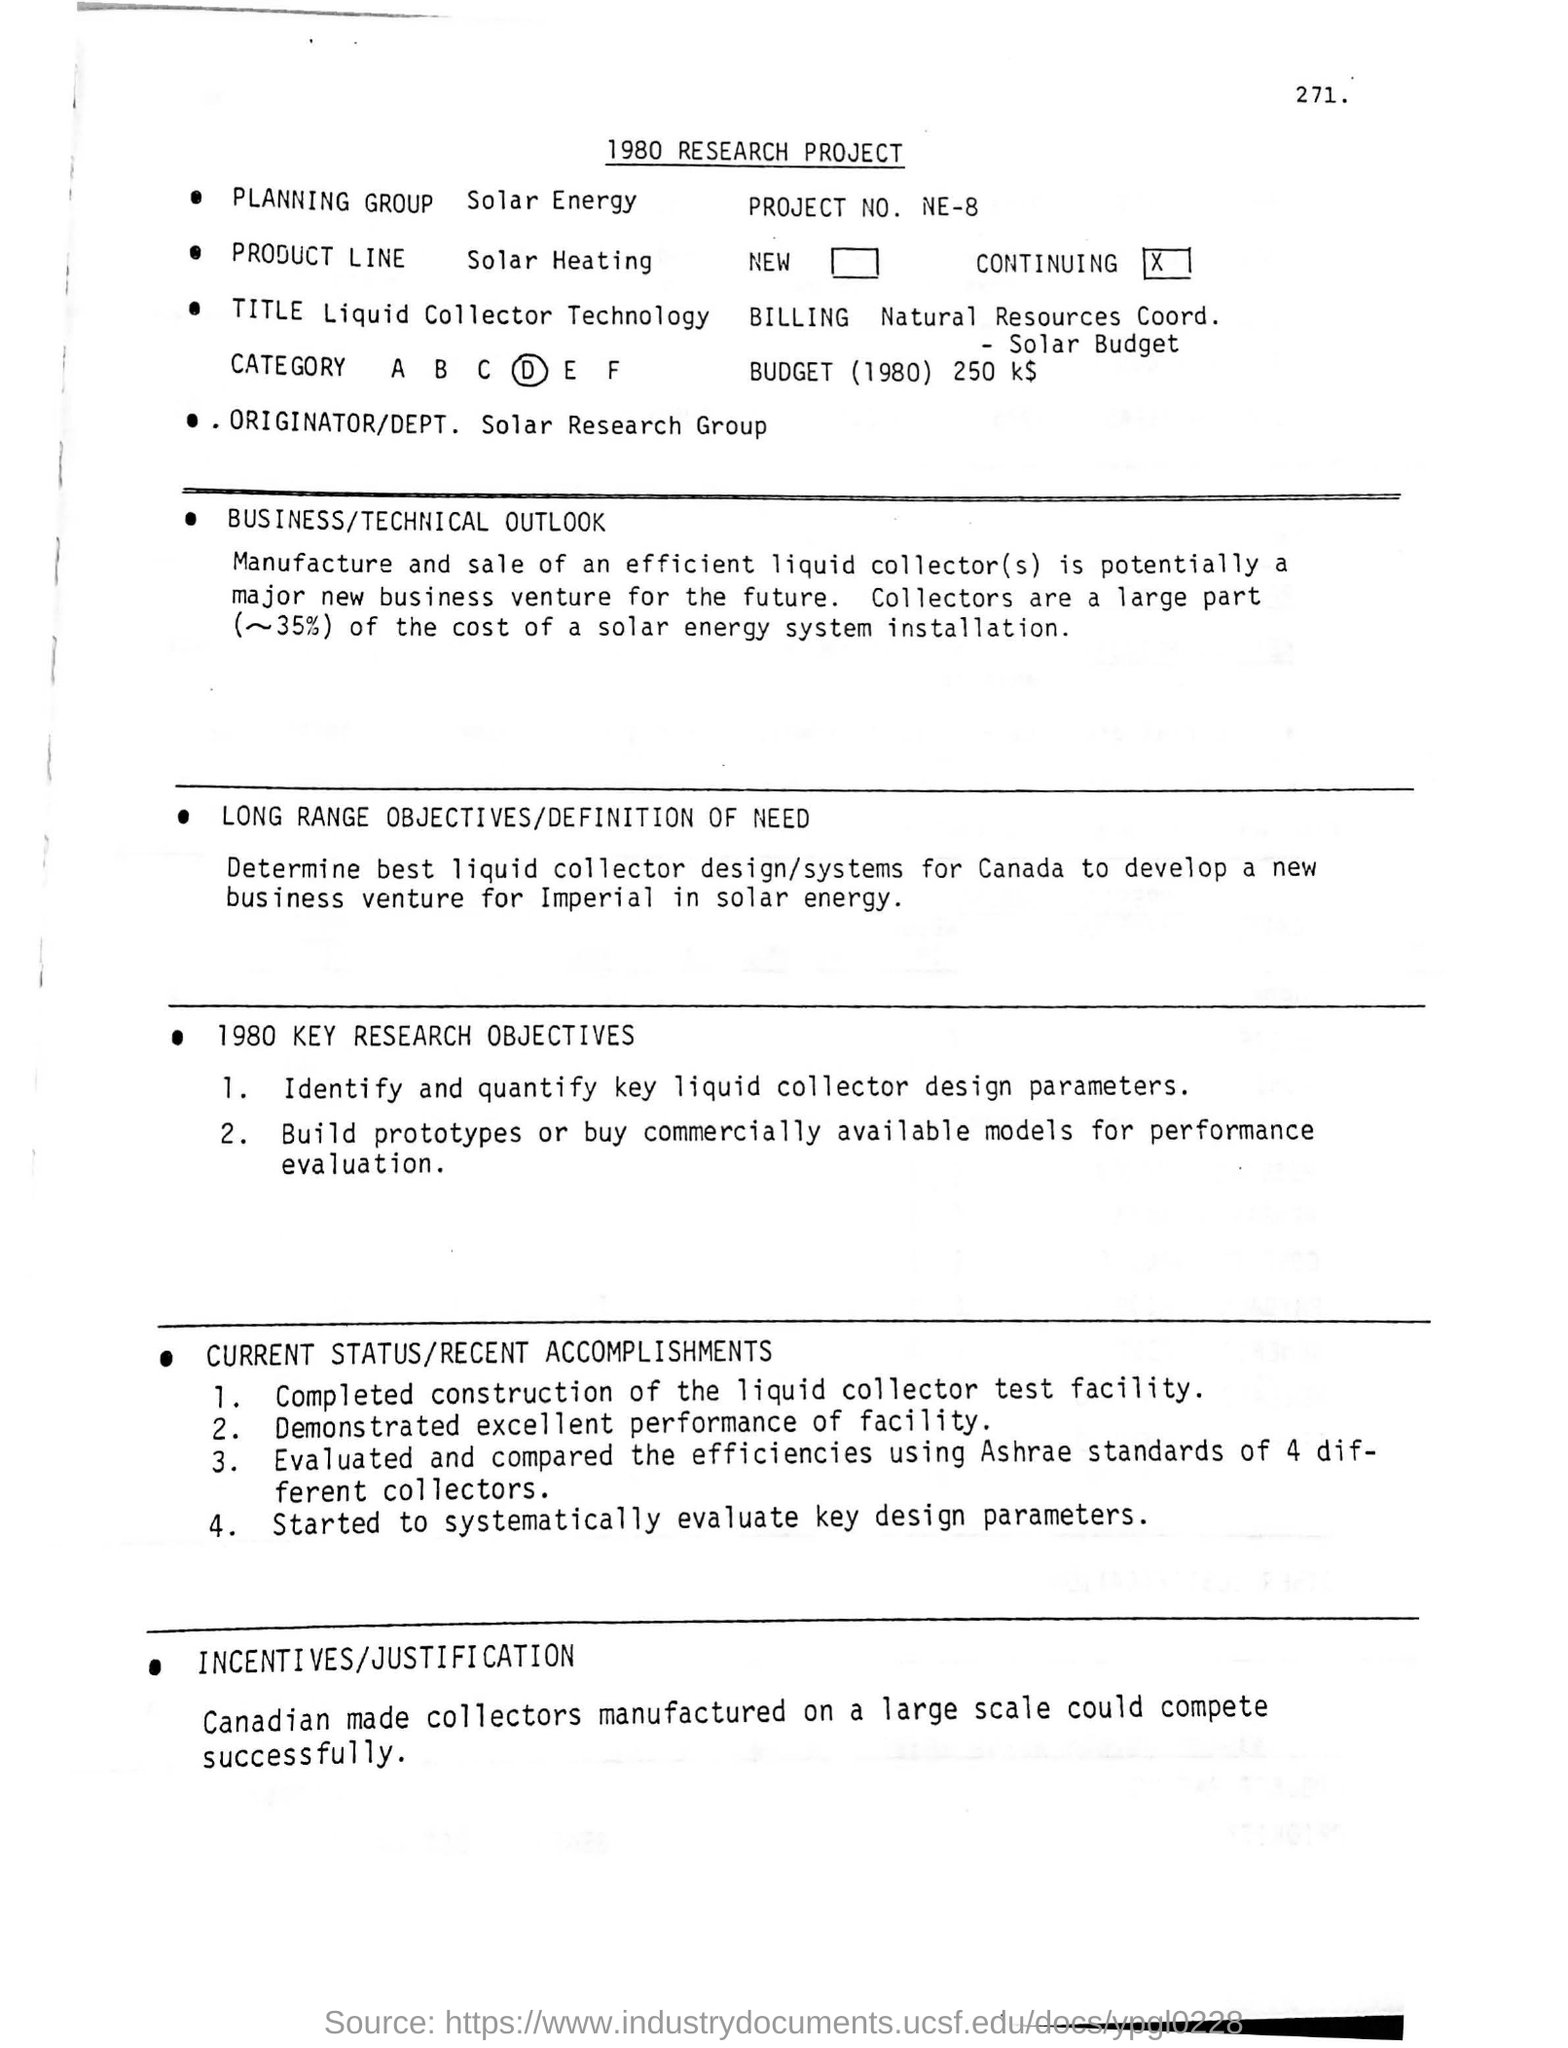What is the 'heading' of the document which is written in top of the document?
Keep it short and to the point. 1980 RESEARCH PROJECT. What is the 'project number'?
Your response must be concise. Ne-8. In which category did project belongs to ?
Provide a short and direct response. D. Who is the 'orginator/dept' of this project?
Make the answer very short. Solar research group. What are the large part of the cost of a solar energy system installation?
Ensure brevity in your answer.  Collectors. For which country ,the best liquid collector design/systems is determined?
Make the answer very short. Canada. Which 'standard' is used to evaluate and compare the efficiencies of 4 different collectors?
Your response must be concise. Ashrae standards. Which product is manufactured on large scale and could compete successfully?
Offer a very short reply. Canadian made collectors. 